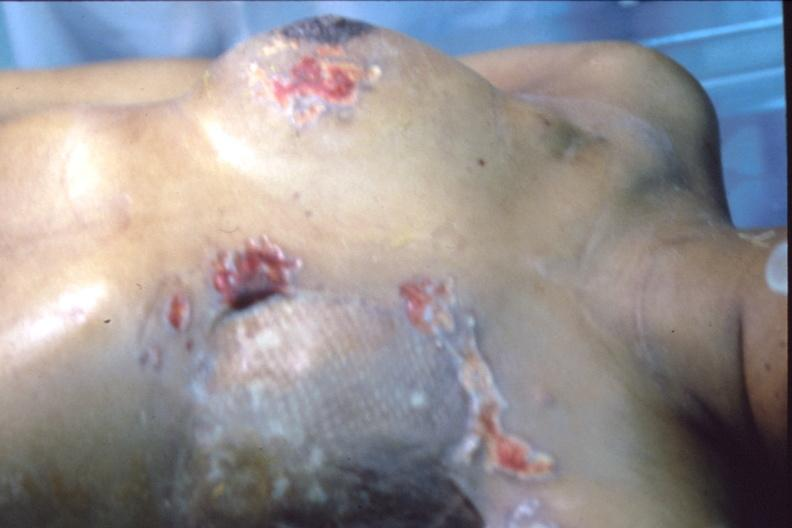does this image show mastectomy scars with skin metastases?
Answer the question using a single word or phrase. Yes 